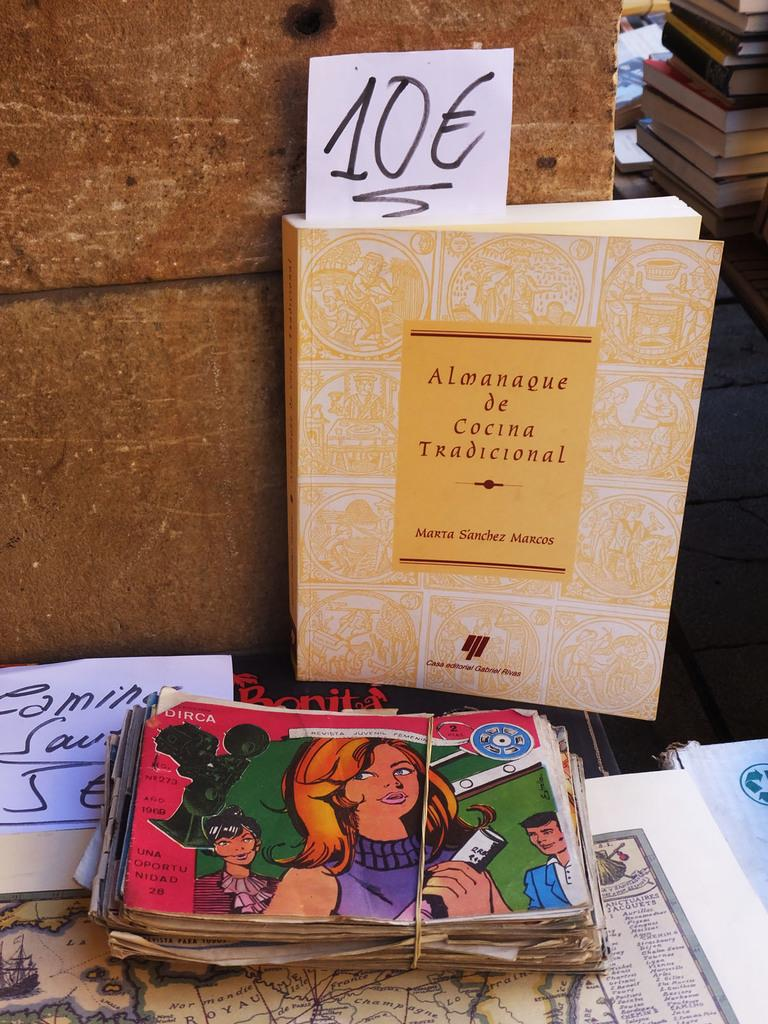<image>
Share a concise interpretation of the image provided. A paperback book by Marta Sanchez Marcos called Almanaque de Cocina Tradicional 